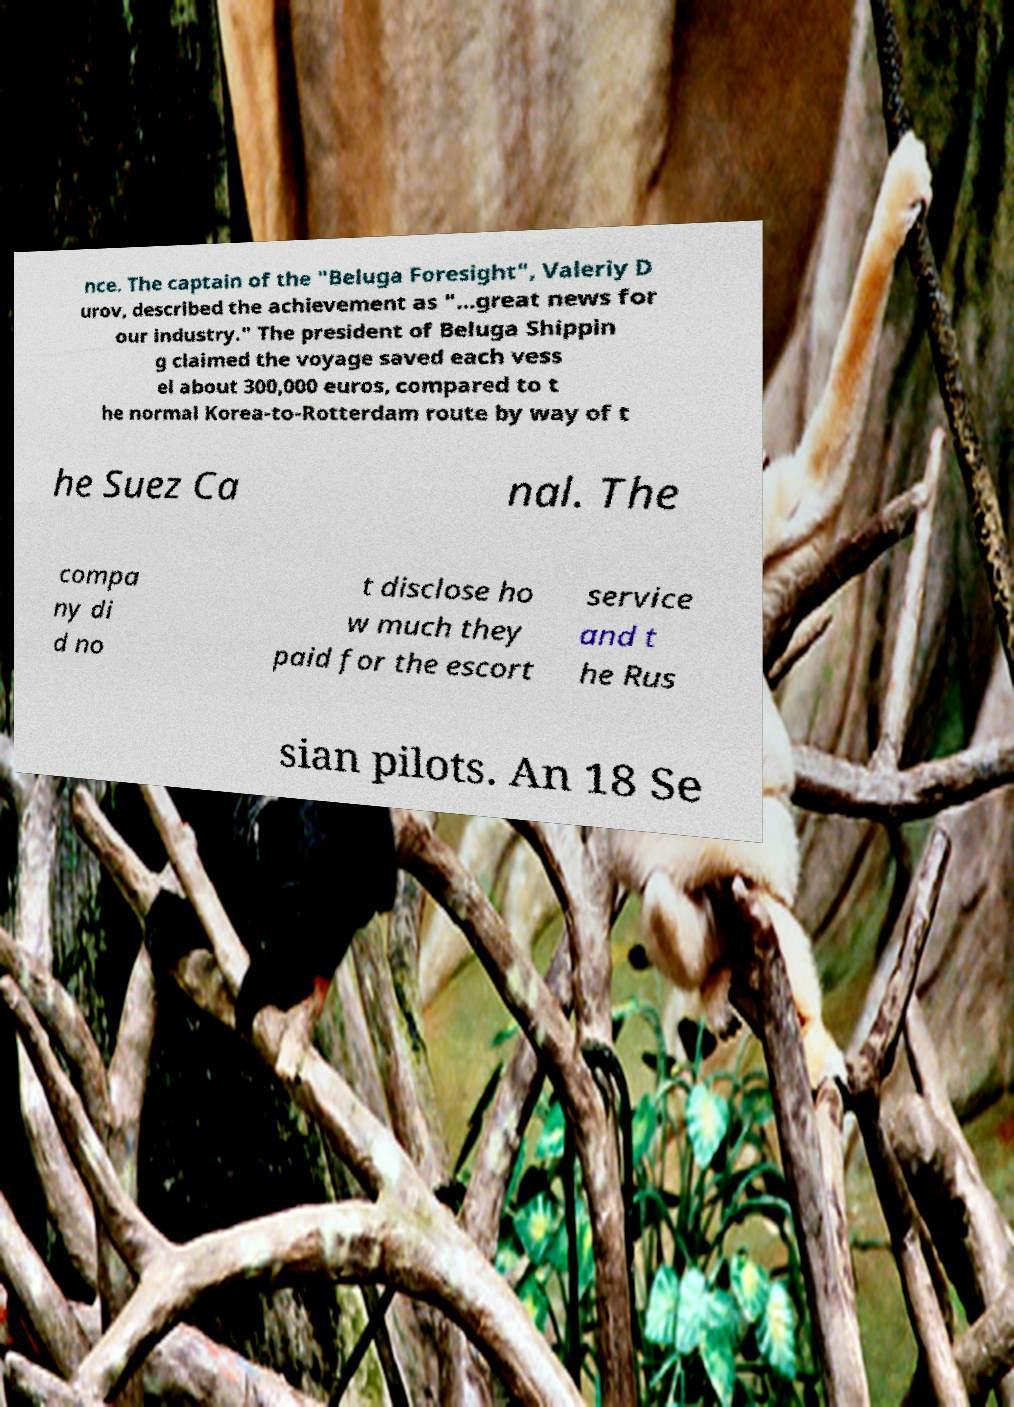Could you extract and type out the text from this image? nce. The captain of the "Beluga Foresight", Valeriy D urov, described the achievement as "...great news for our industry." The president of Beluga Shippin g claimed the voyage saved each vess el about 300,000 euros, compared to t he normal Korea-to-Rotterdam route by way of t he Suez Ca nal. The compa ny di d no t disclose ho w much they paid for the escort service and t he Rus sian pilots. An 18 Se 